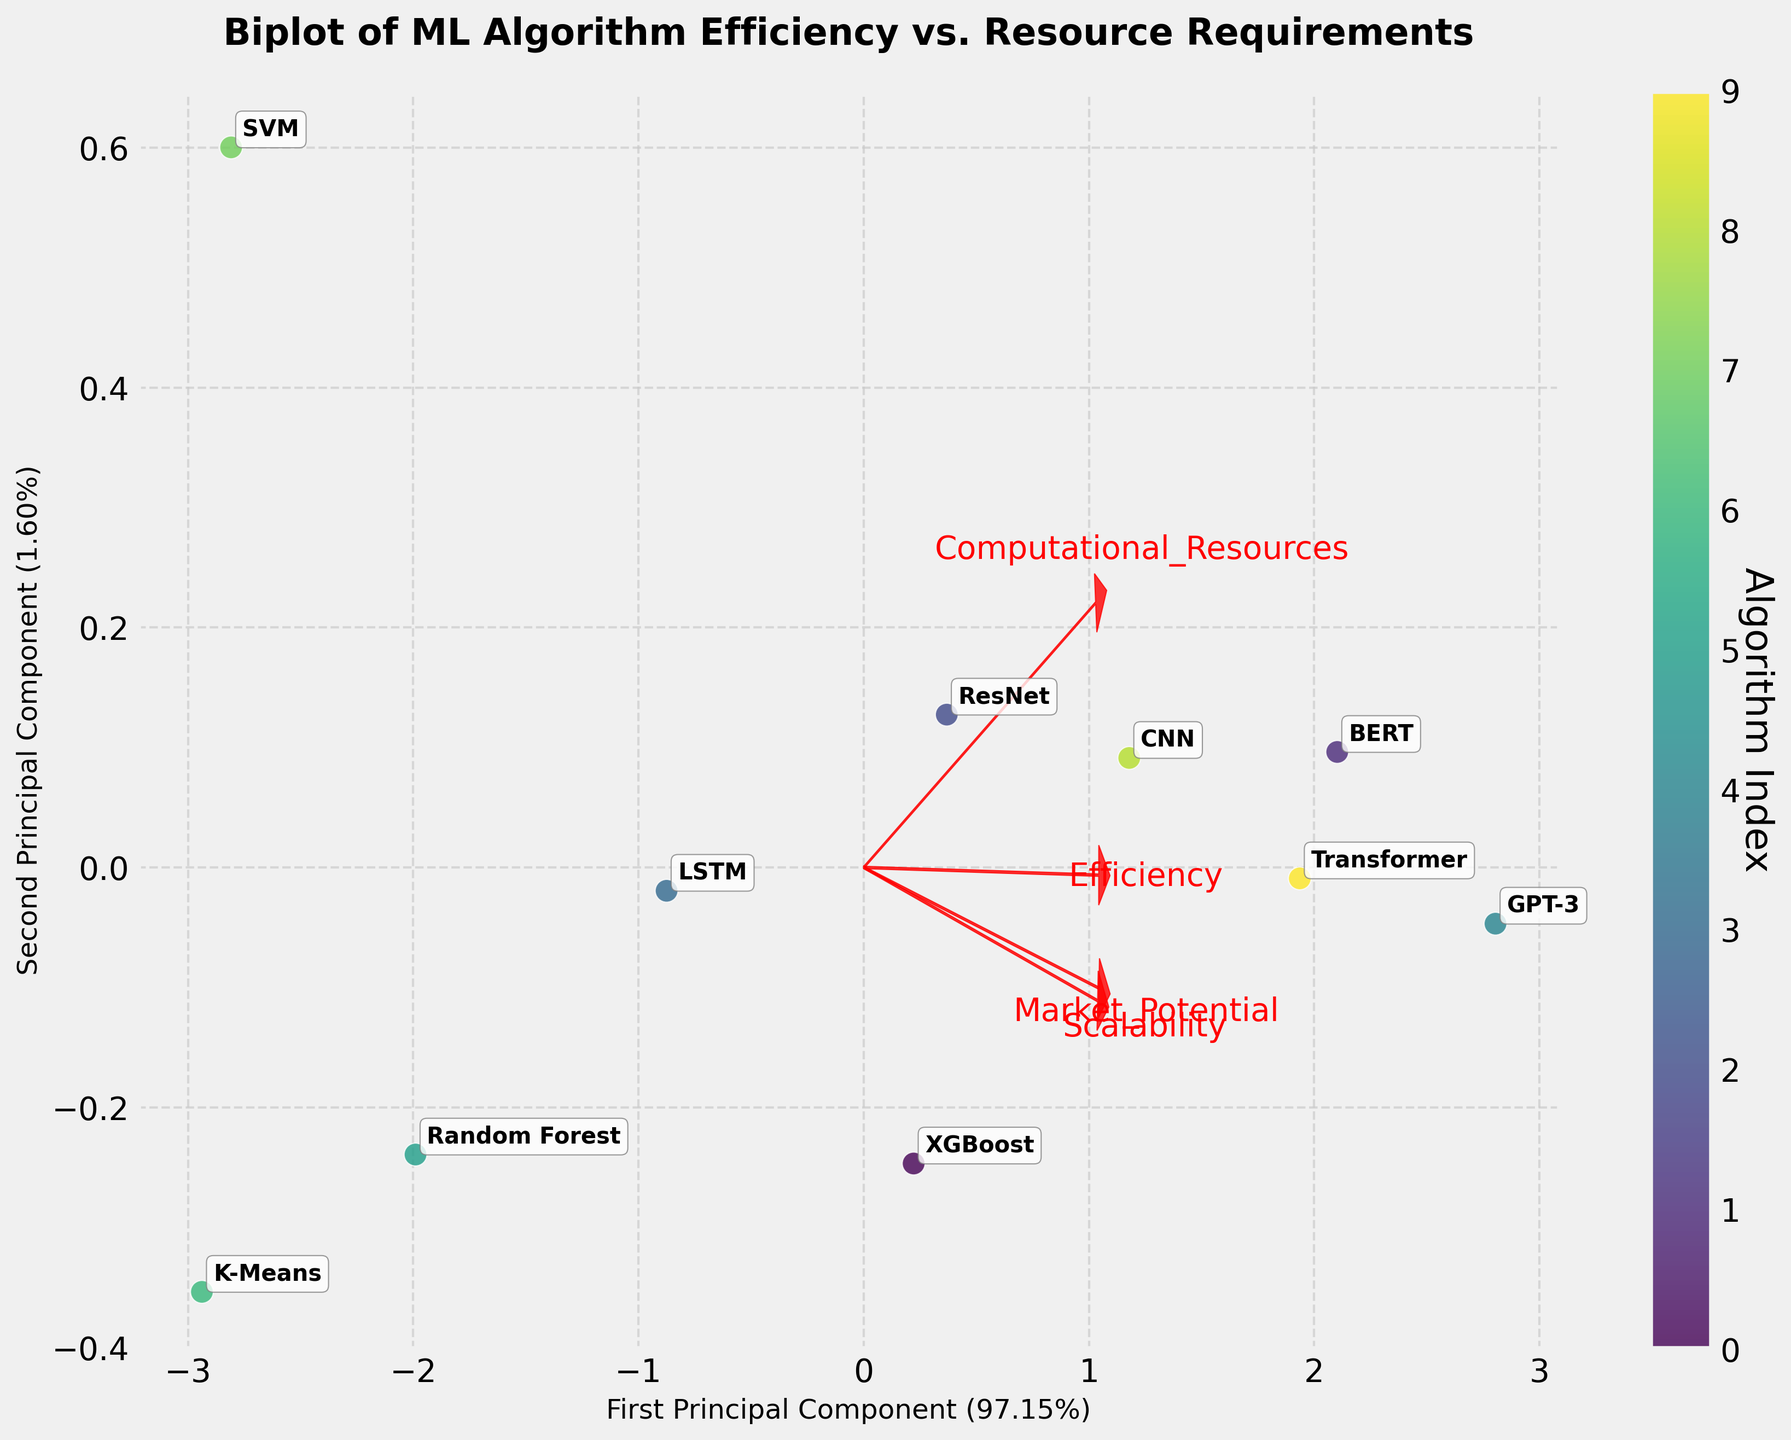What algorithms are shown in the biplot? By looking at the annotations on the points in the biplot, we can list the names of the algorithms shown.
Answer: XGBoost, BERT, ResNet, LSTM, GPT-3, Random Forest, K-Means, SVM, CNN, Transformer Which algorithm appears to have the highest efficiency? From the biplot, identify the point that lies furthest along the direction of the Efficiency arrow.
Answer: GPT-3 Which variable has the least influence on the first principal component? By examining the loadings (arrows) representing each variable, identify the arrow that is shortest in length along the first principal component axis.
Answer: Scalability Between CNN and Transformer, which algorithm requires more computational resources? Compare the positions of CNN and Transformer along the Computational Resources arrow.
Answer: Transformer Which two algorithms have the most similar principal component scores? Look for two points that are closest together on the biplot.
Answer: BERT and Transformer How much variance is explained by the first two principal components? Check the labels of the x-axis and y-axis that specify the explained variance by each principal component.
Answer: Approximately 90% (calculated as the sum of 50% and 40%) Which algorithm has low efficiency but requires high computational resources? Find the point positioned lower along the Efficiency arrow but higher along the Computational Resources arrow.
Answer: BERT Between XGBoost and LSTM, which one has a higher market potential? Compare their positions along the Market Potential arrow.
Answer: XGBoost Which variable contributes almost equally to both principal components? Identify the arrow that is roughly at a 45-degree angle between the two principal component axes.
Answer: Market Potential Is there any algorithm that does not align well with the Scalability variable? Look for an algorithm point that is far from the direction of the Scalability arrow.
Answer: SVM 